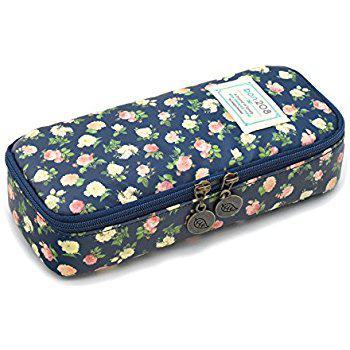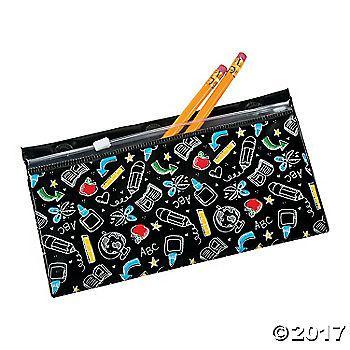The first image is the image on the left, the second image is the image on the right. For the images shown, is this caption "There are flowers on the case in the image on the left." true? Answer yes or no. Yes. The first image is the image on the left, the second image is the image on the right. Given the left and right images, does the statement "The pencil case in the right image is predominantly pink." hold true? Answer yes or no. No. 